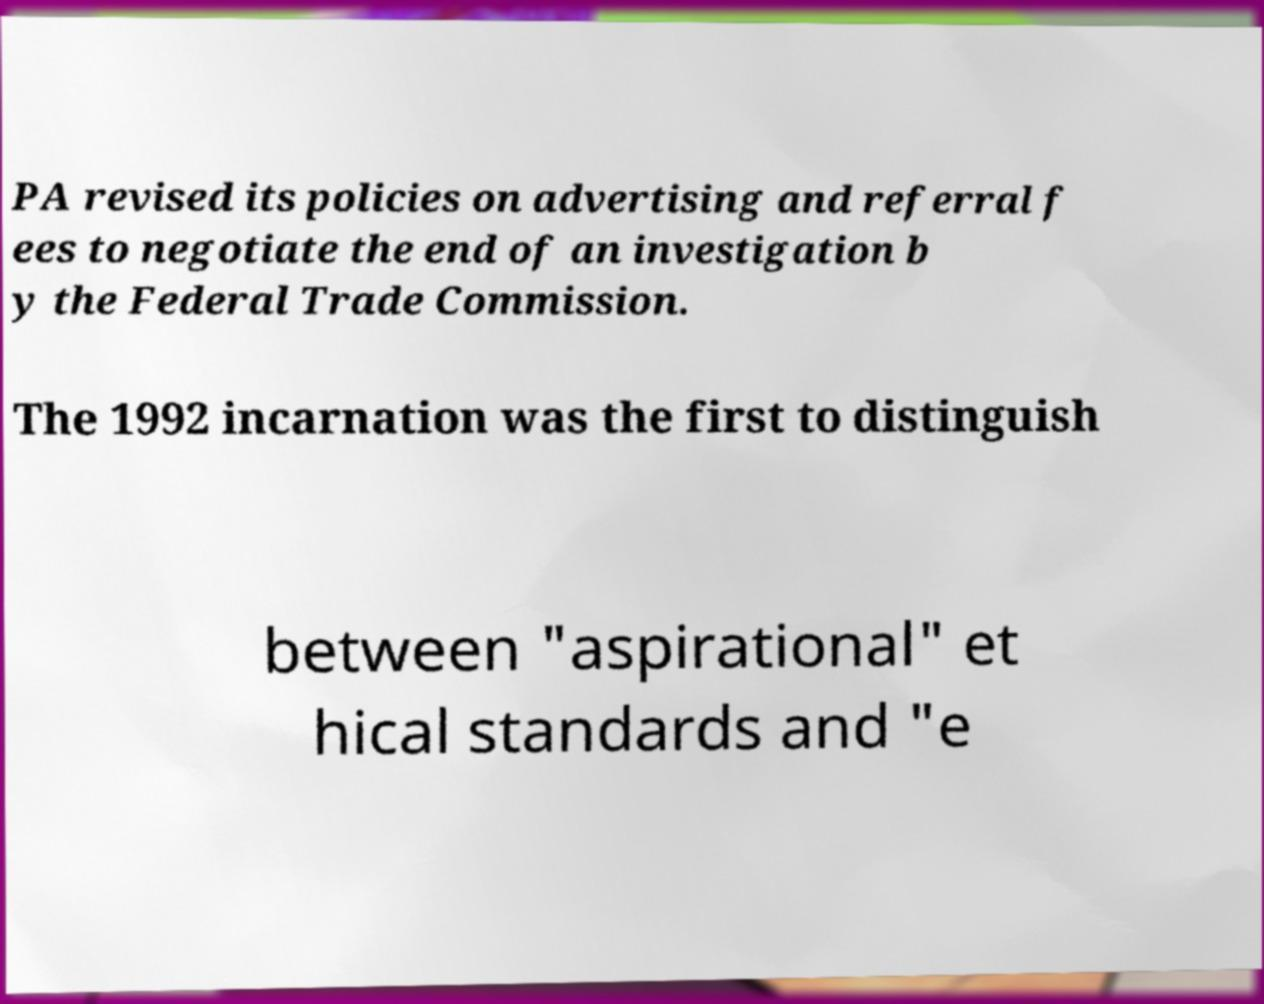Could you extract and type out the text from this image? PA revised its policies on advertising and referral f ees to negotiate the end of an investigation b y the Federal Trade Commission. The 1992 incarnation was the first to distinguish between "aspirational" et hical standards and "e 